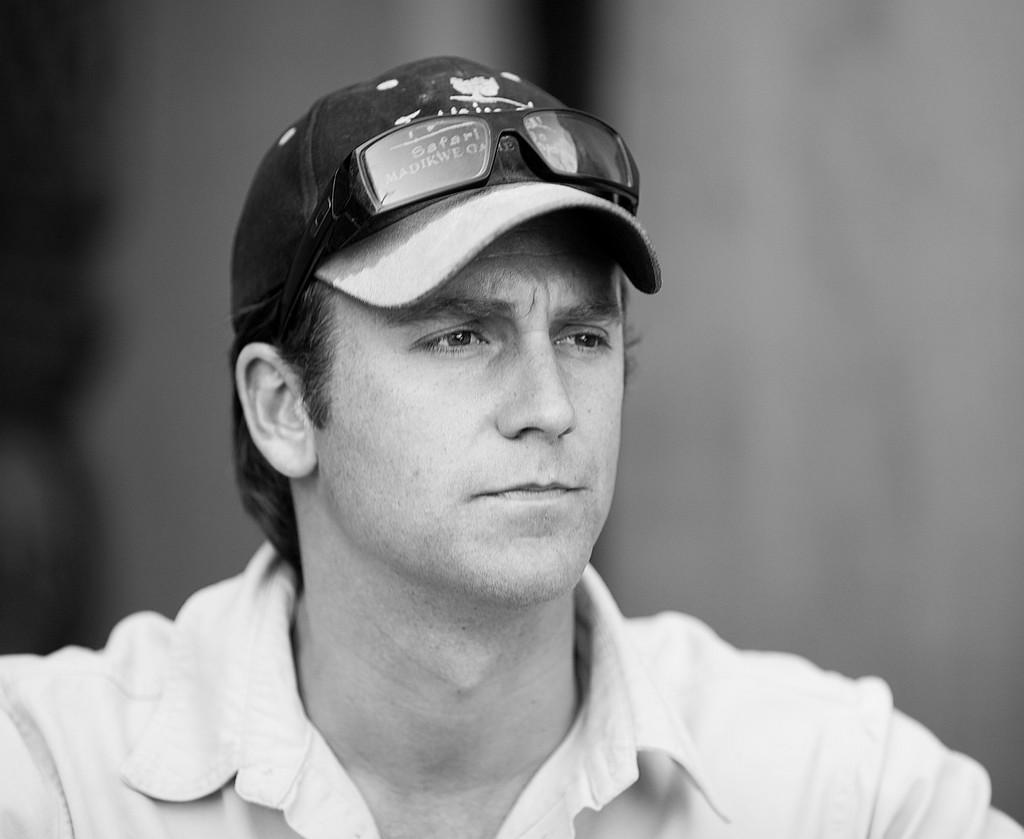What type of headwear is the person in the image wearing? The person in the image is wearing a cap. What type of eyewear is the person in the image wearing? The person in the image is wearing spectacles. Can you describe the background of the image? The background of the image is blurry. What type of bait is the person in the image using? There is no bait present in the image; the person is wearing a cap and spectacles. How many rings can be seen on the person's fingers in the image? There is no mention of rings in the image; the person is wearing a cap and spectacles. 